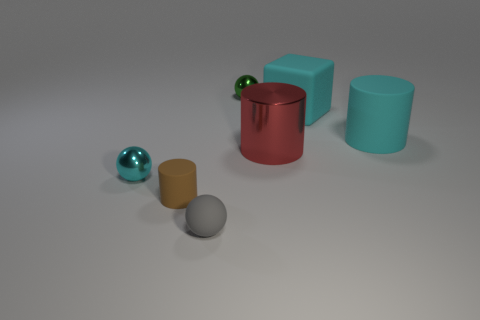Does the big rubber cylinder have the same color as the large block?
Provide a succinct answer. Yes. There is a small metallic sphere that is left of the tiny brown object; what color is it?
Provide a short and direct response. Cyan. How many matte cylinders are the same color as the rubber cube?
Provide a short and direct response. 1. Are there fewer gray spheres behind the tiny brown matte object than spheres in front of the cyan metallic sphere?
Offer a terse response. Yes. What number of big rubber things are behind the small cyan sphere?
Your answer should be compact. 2. Are there any other big red things made of the same material as the big red thing?
Your response must be concise. No. Are there more tiny brown objects on the right side of the metallic cylinder than green things to the right of the gray thing?
Provide a succinct answer. No. The cyan cylinder is what size?
Make the answer very short. Large. What shape is the big cyan rubber object that is behind the cyan matte cylinder?
Your response must be concise. Cube. Does the red object have the same shape as the small brown object?
Your answer should be very brief. Yes. 